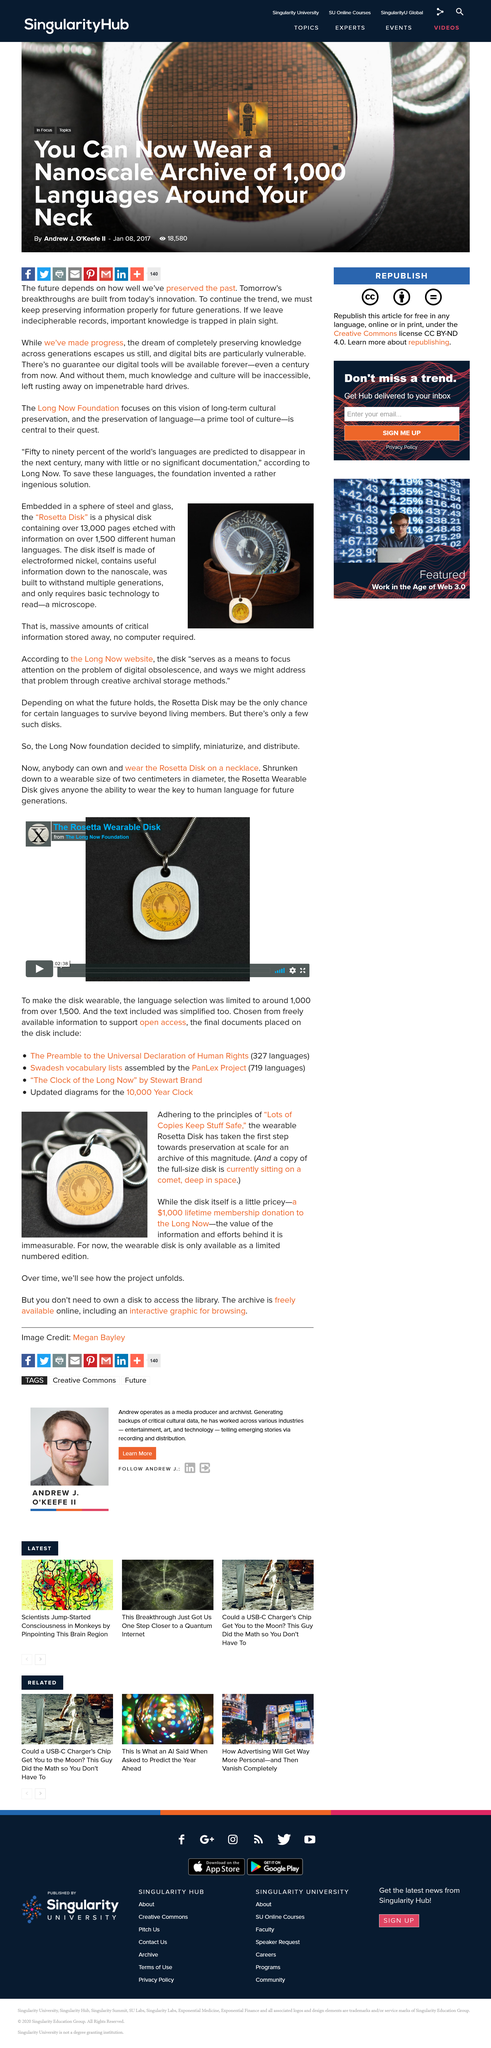Identify some key points in this picture. The Rosetta Disk is relatively expensive. The disk is made of electroformed nickel, which is confirmed by the answer "Yes. The Rosetta Disk contains more than 13,000 pages. The Rosetta Disk is featured in the image and is a disk that is used to store information. It is not necessary for readers to own a Rosetta Disk in order to access the library. 